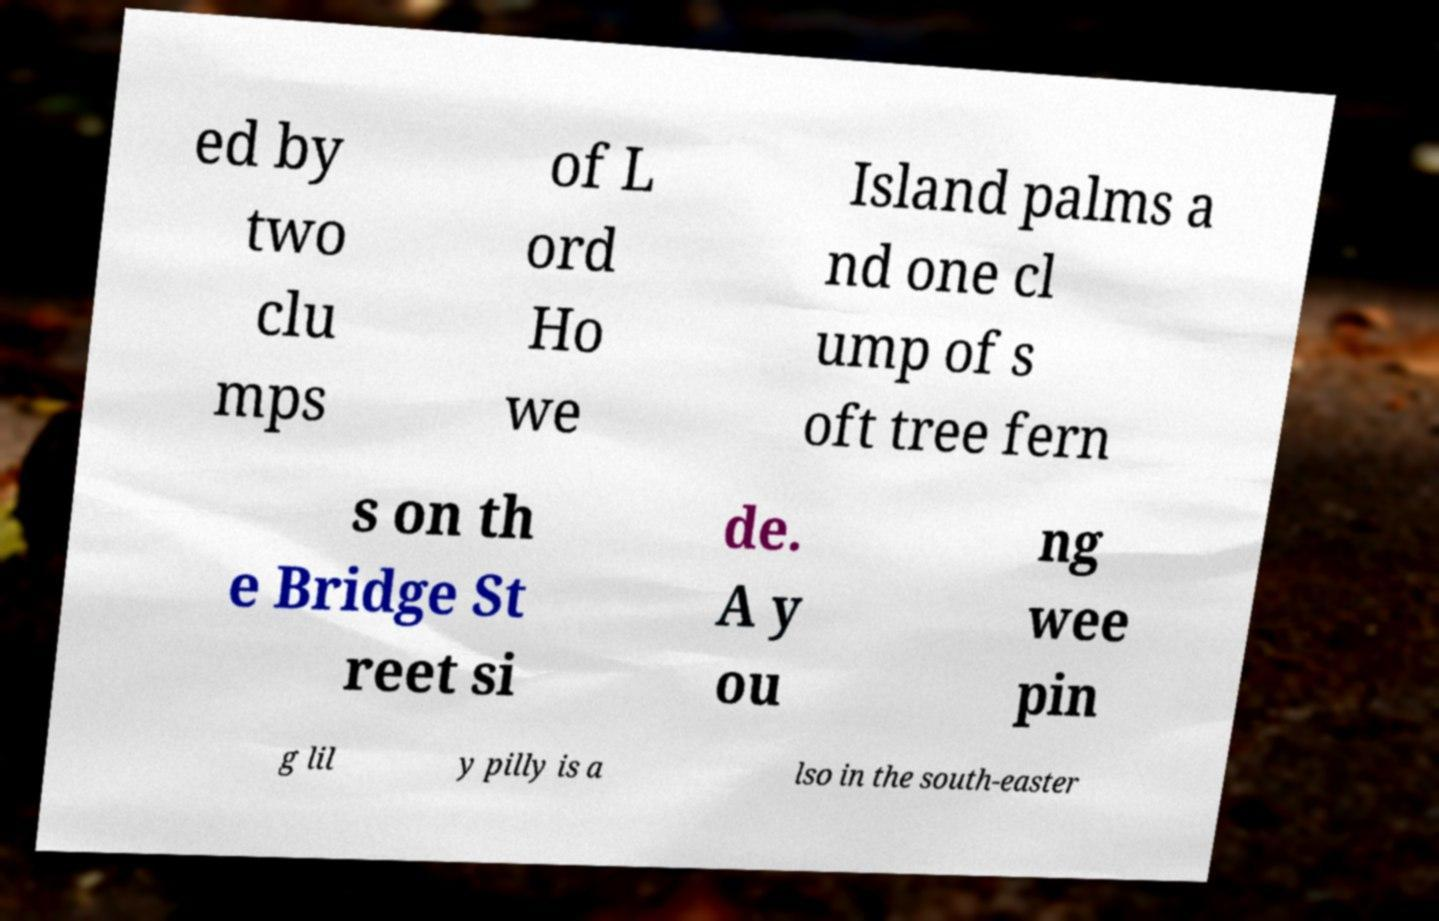Could you assist in decoding the text presented in this image and type it out clearly? ed by two clu mps of L ord Ho we Island palms a nd one cl ump of s oft tree fern s on th e Bridge St reet si de. A y ou ng wee pin g lil y pilly is a lso in the south-easter 